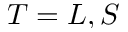Convert formula to latex. <formula><loc_0><loc_0><loc_500><loc_500>T = L , S</formula> 